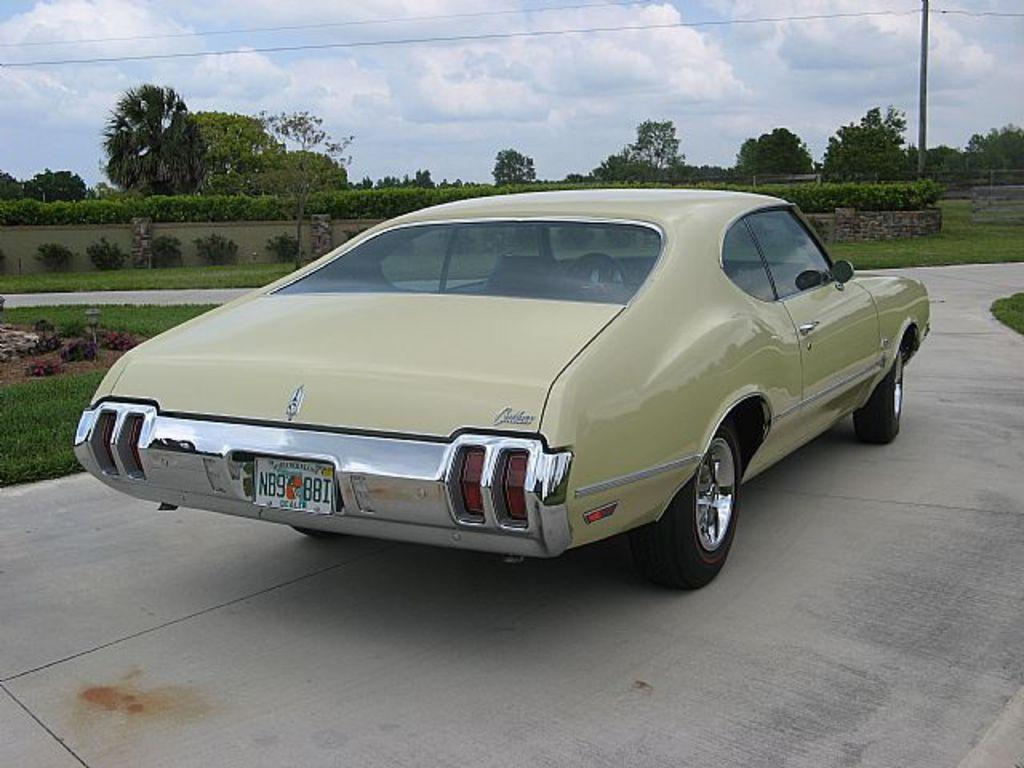What is the main subject of the image? There is a car on a road in the image. What can be seen in the background of the image? There is a grassland, plants, trees, poles, and the sky visible in the background of the image. What scent can be detected coming from the worm in the image? There is no worm present in the image, so it is not possible to detect any scent. 